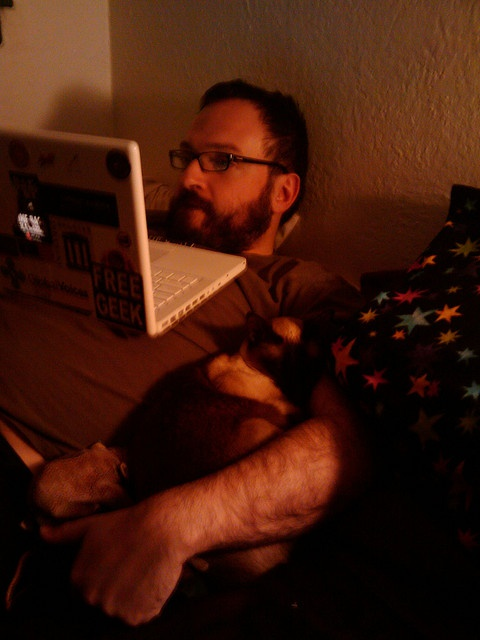Describe the objects in this image and their specific colors. I can see people in black, maroon, and brown tones, bed in black and maroon tones, laptop in black, maroon, tan, and brown tones, and cat in black, maroon, and red tones in this image. 